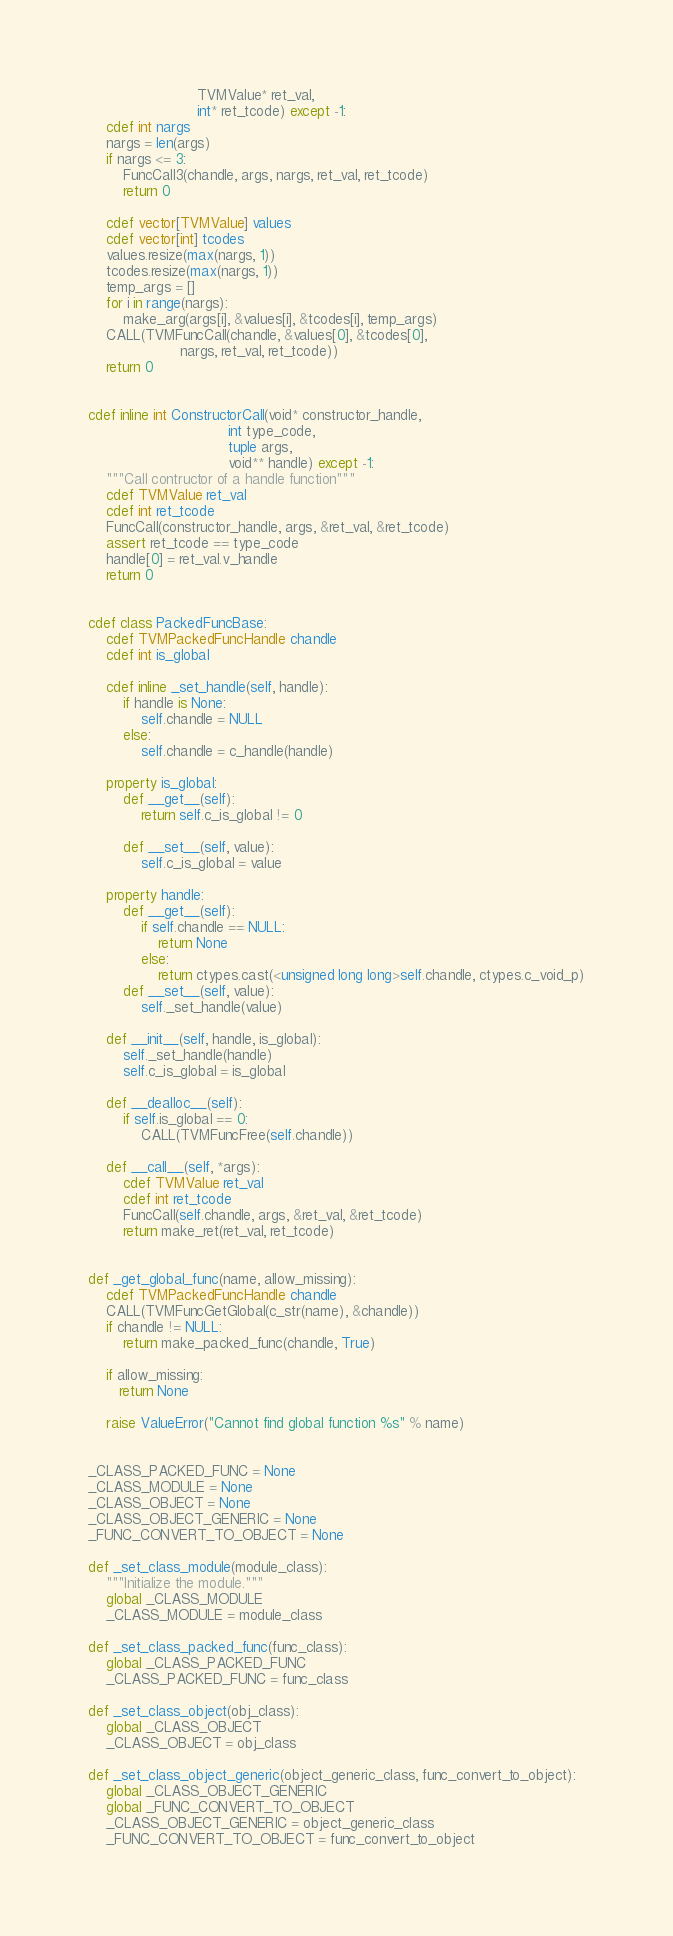Convert code to text. <code><loc_0><loc_0><loc_500><loc_500><_Cython_>                         TVMValue* ret_val,
                         int* ret_tcode) except -1:
    cdef int nargs
    nargs = len(args)
    if nargs <= 3:
        FuncCall3(chandle, args, nargs, ret_val, ret_tcode)
        return 0

    cdef vector[TVMValue] values
    cdef vector[int] tcodes
    values.resize(max(nargs, 1))
    tcodes.resize(max(nargs, 1))
    temp_args = []
    for i in range(nargs):
        make_arg(args[i], &values[i], &tcodes[i], temp_args)
    CALL(TVMFuncCall(chandle, &values[0], &tcodes[0],
                     nargs, ret_val, ret_tcode))
    return 0


cdef inline int ConstructorCall(void* constructor_handle,
                                int type_code,
                                tuple args,
                                void** handle) except -1:
    """Call contructor of a handle function"""
    cdef TVMValue ret_val
    cdef int ret_tcode
    FuncCall(constructor_handle, args, &ret_val, &ret_tcode)
    assert ret_tcode == type_code
    handle[0] = ret_val.v_handle
    return 0


cdef class PackedFuncBase:
    cdef TVMPackedFuncHandle chandle
    cdef int is_global

    cdef inline _set_handle(self, handle):
        if handle is None:
            self.chandle = NULL
        else:
            self.chandle = c_handle(handle)

    property is_global:
        def __get__(self):
            return self.c_is_global != 0

        def __set__(self, value):
            self.c_is_global = value

    property handle:
        def __get__(self):
            if self.chandle == NULL:
                return None
            else:
                return ctypes.cast(<unsigned long long>self.chandle, ctypes.c_void_p)
        def __set__(self, value):
            self._set_handle(value)

    def __init__(self, handle, is_global):
        self._set_handle(handle)
        self.c_is_global = is_global

    def __dealloc__(self):
        if self.is_global == 0:
            CALL(TVMFuncFree(self.chandle))

    def __call__(self, *args):
        cdef TVMValue ret_val
        cdef int ret_tcode
        FuncCall(self.chandle, args, &ret_val, &ret_tcode)
        return make_ret(ret_val, ret_tcode)


def _get_global_func(name, allow_missing):
    cdef TVMPackedFuncHandle chandle
    CALL(TVMFuncGetGlobal(c_str(name), &chandle))
    if chandle != NULL:
        return make_packed_func(chandle, True)

    if allow_missing:
       return None

    raise ValueError("Cannot find global function %s" % name)


_CLASS_PACKED_FUNC = None
_CLASS_MODULE = None
_CLASS_OBJECT = None
_CLASS_OBJECT_GENERIC = None
_FUNC_CONVERT_TO_OBJECT = None

def _set_class_module(module_class):
    """Initialize the module."""
    global _CLASS_MODULE
    _CLASS_MODULE = module_class

def _set_class_packed_func(func_class):
    global _CLASS_PACKED_FUNC
    _CLASS_PACKED_FUNC = func_class

def _set_class_object(obj_class):
    global _CLASS_OBJECT
    _CLASS_OBJECT = obj_class

def _set_class_object_generic(object_generic_class, func_convert_to_object):
    global _CLASS_OBJECT_GENERIC
    global _FUNC_CONVERT_TO_OBJECT
    _CLASS_OBJECT_GENERIC = object_generic_class
    _FUNC_CONVERT_TO_OBJECT = func_convert_to_object
</code> 